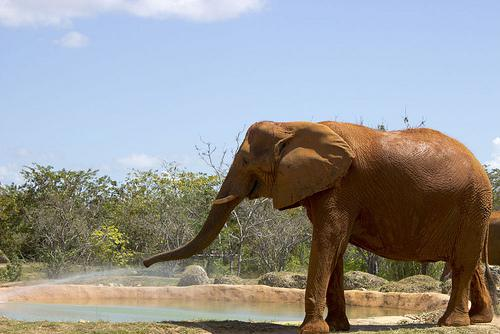Question: when was the photo taken?
Choices:
A. Daytime.
B. Yesterday.
C. Today.
D. Noon.
Answer with the letter. Answer: A Question: what color is the animal?
Choices:
A. Brown.
B. White.
C. Black.
D. Grey.
Answer with the letter. Answer: A Question: how many of the elephants legs are shown?
Choices:
A. 5.
B. 4.
C. 3.
D. 1.
Answer with the letter. Answer: B Question: how many animals are in focus?
Choices:
A. Two.
B. Three.
C. One.
D. Four.
Answer with the letter. Answer: C Question: what kind of animal is shown?
Choices:
A. Giraffe.
B. Zebra.
C. Cow.
D. Elephant.
Answer with the letter. Answer: D Question: where are the front feet of the elephant?
Choices:
A. In the air.
B. On grass.
C. On a stool.
D. In the dirt.
Answer with the letter. Answer: B Question: what color is the sky?
Choices:
A. White.
B. Grey.
C. Blue.
D. Clear.
Answer with the letter. Answer: C 